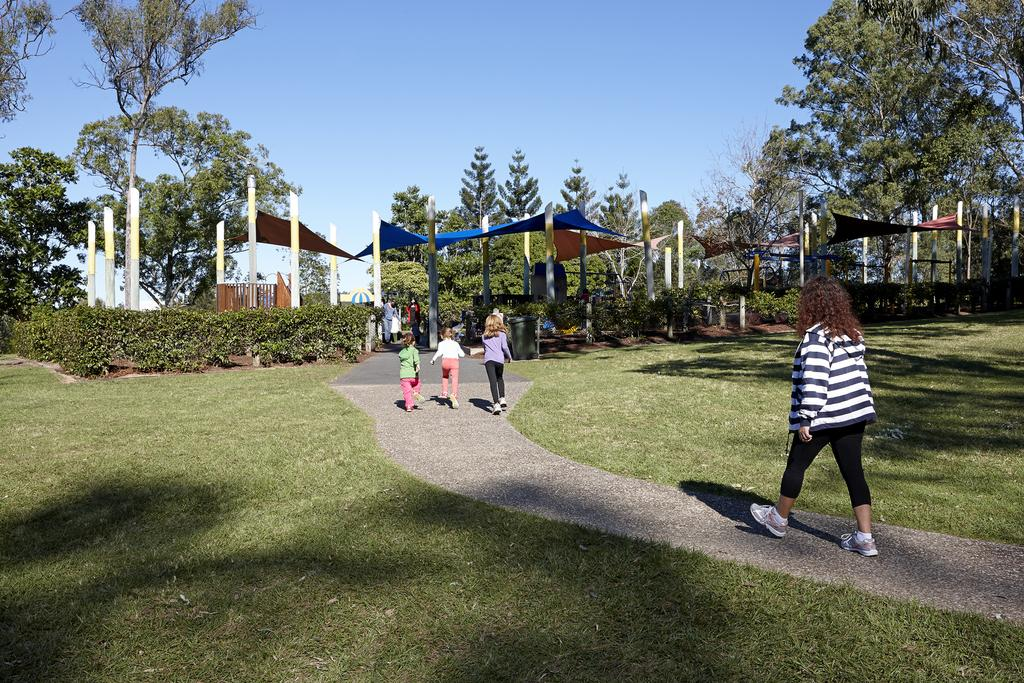How many kids are in the image? There are three kids in the image. Who else is present in the image besides the kids? There is a woman in the image. What are the people in the image doing? The people are walking on a pavement. What can be seen beside the pavement? There is grass beside the pavement. What is visible in the background of the image? There are plants and trees in the background of the image. What type of vegetable is being discussed in the meeting in the image? There is no meeting or discussion of vegetables present in the image; it features three kids and a woman walking on a pavement. 